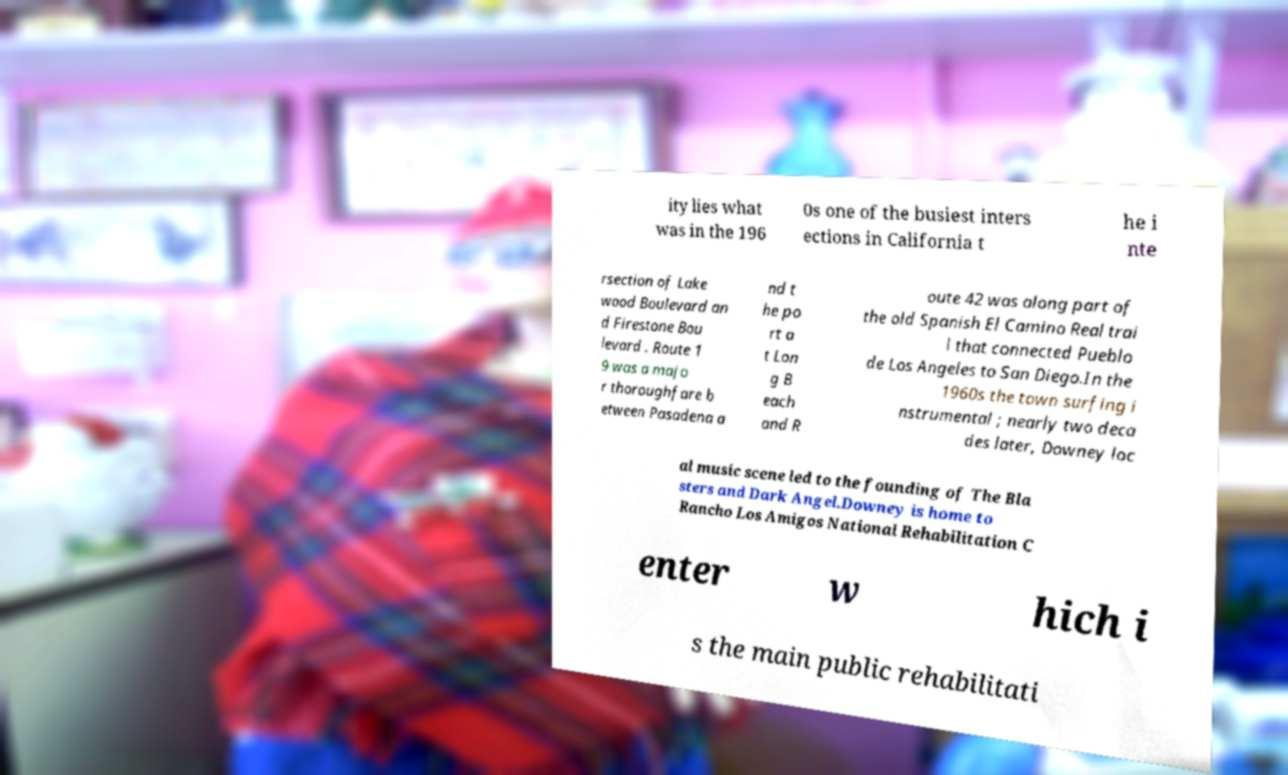For documentation purposes, I need the text within this image transcribed. Could you provide that? ity lies what was in the 196 0s one of the busiest inters ections in California t he i nte rsection of Lake wood Boulevard an d Firestone Bou levard . Route 1 9 was a majo r thoroughfare b etween Pasadena a nd t he po rt a t Lon g B each and R oute 42 was along part of the old Spanish El Camino Real trai l that connected Pueblo de Los Angeles to San Diego.In the 1960s the town surfing i nstrumental ; nearly two deca des later, Downey loc al music scene led to the founding of The Bla sters and Dark Angel.Downey is home to Rancho Los Amigos National Rehabilitation C enter w hich i s the main public rehabilitati 